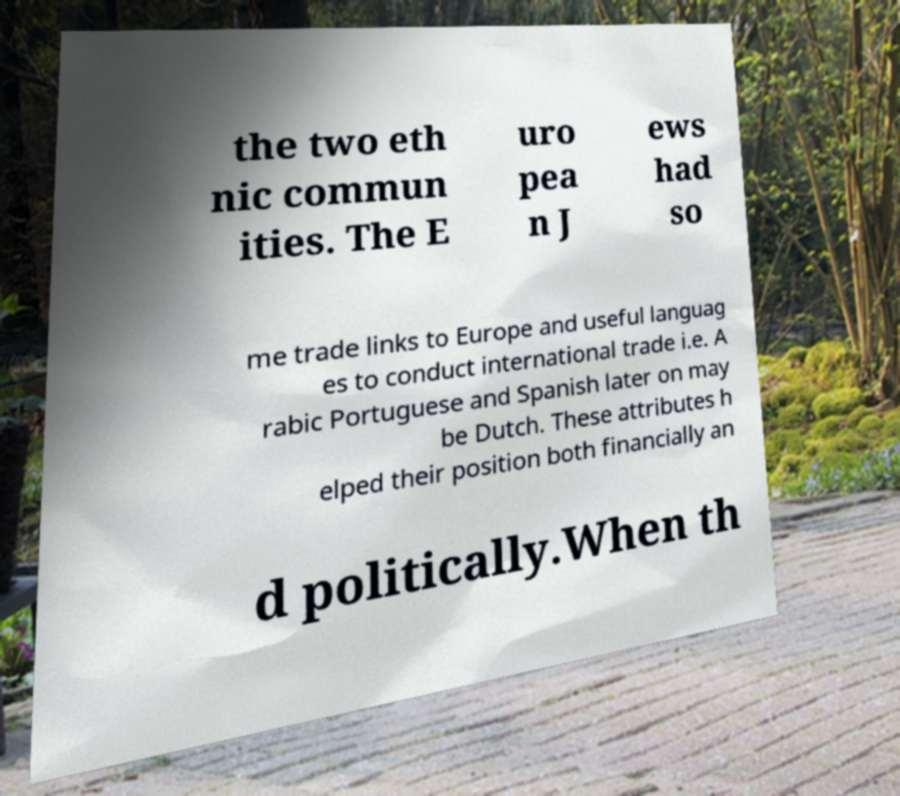Can you read and provide the text displayed in the image?This photo seems to have some interesting text. Can you extract and type it out for me? the two eth nic commun ities. The E uro pea n J ews had so me trade links to Europe and useful languag es to conduct international trade i.e. A rabic Portuguese and Spanish later on may be Dutch. These attributes h elped their position both financially an d politically.When th 